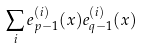Convert formula to latex. <formula><loc_0><loc_0><loc_500><loc_500>\sum _ { i } e _ { p - 1 } ^ { ( i ) } ( x ) e _ { q - 1 } ^ { ( i ) } ( x )</formula> 